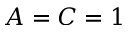Convert formula to latex. <formula><loc_0><loc_0><loc_500><loc_500>A = C = 1</formula> 